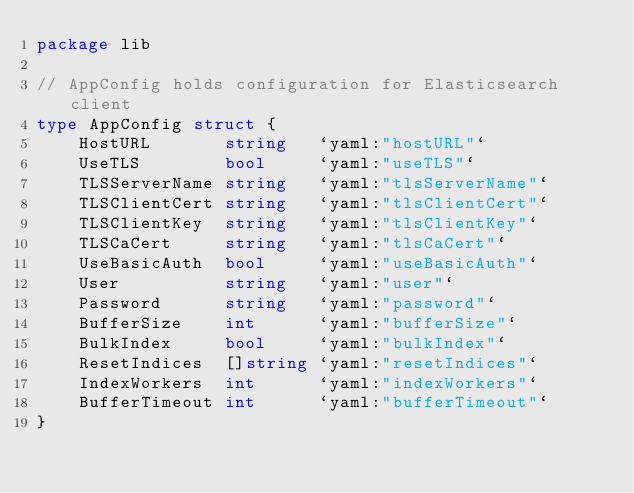<code> <loc_0><loc_0><loc_500><loc_500><_Go_>package lib

// AppConfig holds configuration for Elasticsearch client
type AppConfig struct {
	HostURL       string   `yaml:"hostURL"`
	UseTLS        bool     `yaml:"useTLS"`
	TLSServerName string   `yaml:"tlsServerName"`
	TLSClientCert string   `yaml:"tlsClientCert"`
	TLSClientKey  string   `yaml:"tlsClientKey"`
	TLSCaCert     string   `yaml:"tlsCaCert"`
	UseBasicAuth  bool     `yaml:"useBasicAuth"`
	User          string   `yaml:"user"`
	Password      string   `yaml:"password"`
	BufferSize    int      `yaml:"bufferSize"`
	BulkIndex     bool     `yaml:"bulkIndex"`
	ResetIndices  []string `yaml:"resetIndices"`
	IndexWorkers  int      `yaml:"indexWorkers"`
	BufferTimeout int      `yaml:"bufferTimeout"`
}
</code> 